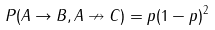<formula> <loc_0><loc_0><loc_500><loc_500>P ( A \rightarrow B , A \nrightarrow C ) = p ( 1 - p ) ^ { 2 }</formula> 